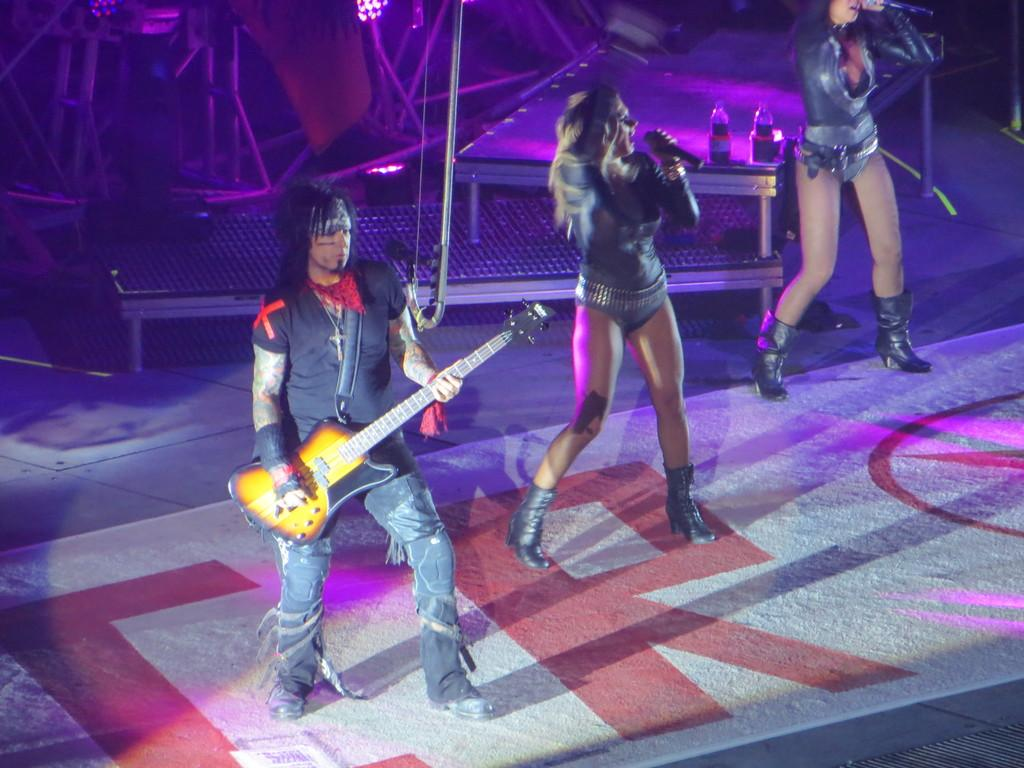What is the person in the image doing? There is a person playing guitar in the image. What are the women in the image doing? There are two women singing in front of mics in the image. What can be seen on the table in the image? There are bottles on a table in the image. What type of light is present in the image? There is a focusing light in the image. What type of grass is growing on the cart in the image? There is no grass or cart present in the image. What material is the silk used for in the image? There is no silk present in the image. 